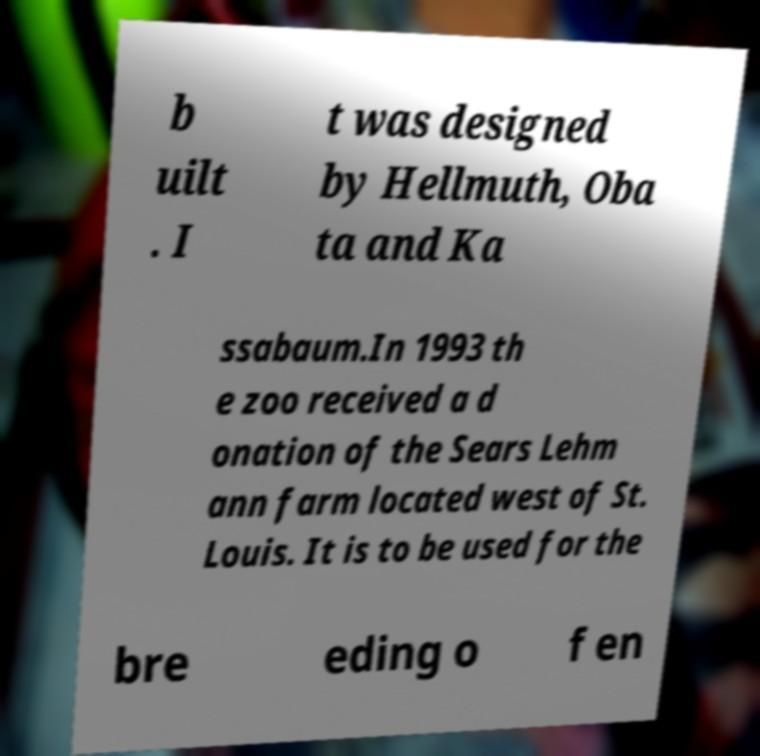I need the written content from this picture converted into text. Can you do that? b uilt . I t was designed by Hellmuth, Oba ta and Ka ssabaum.In 1993 th e zoo received a d onation of the Sears Lehm ann farm located west of St. Louis. It is to be used for the bre eding o f en 